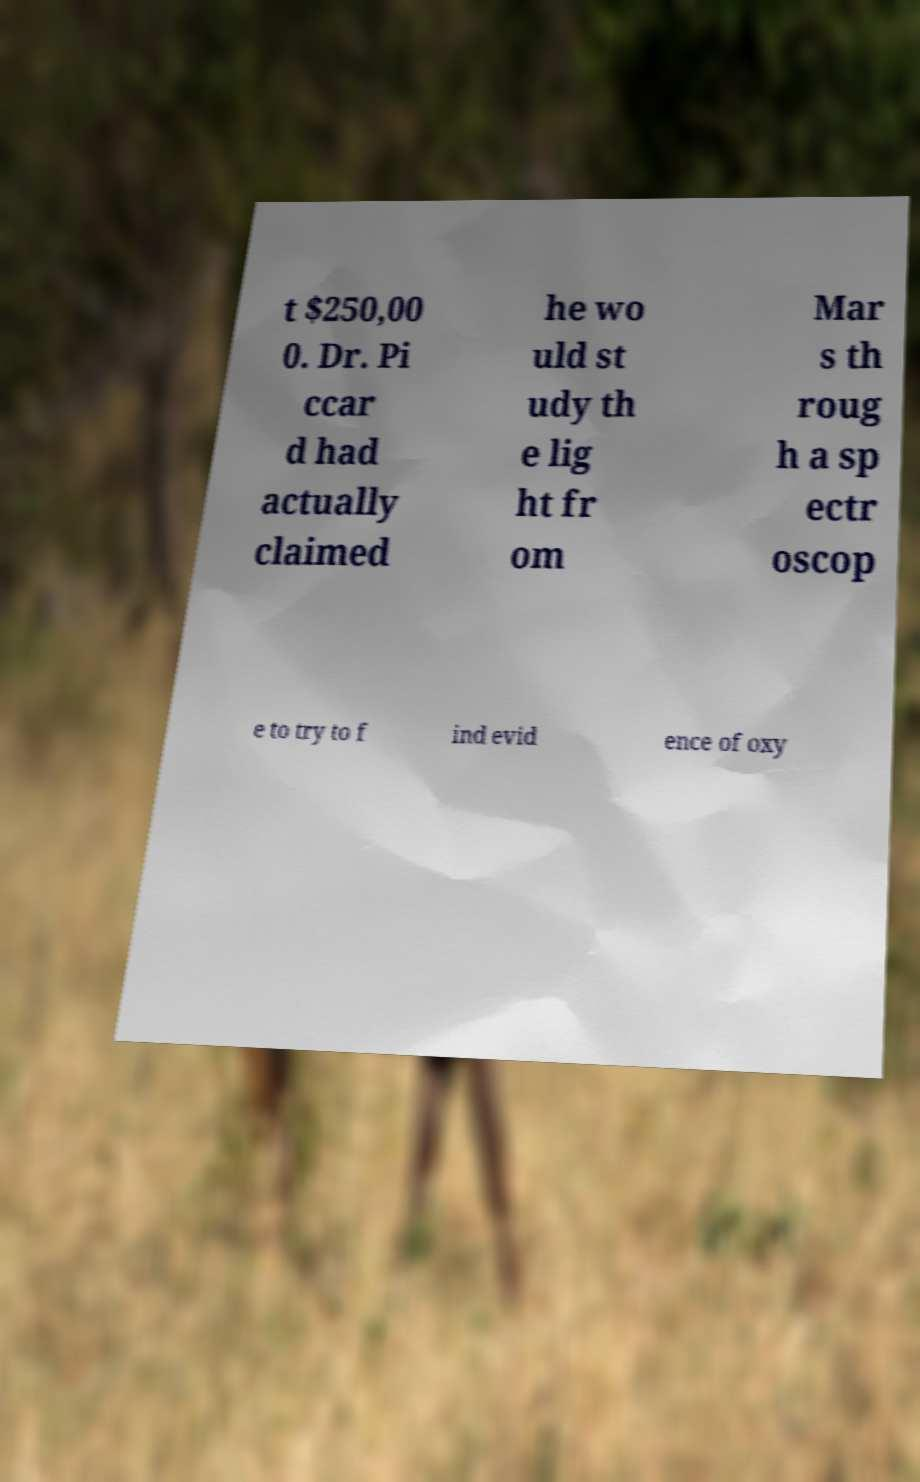Can you read and provide the text displayed in the image?This photo seems to have some interesting text. Can you extract and type it out for me? t $250,00 0. Dr. Pi ccar d had actually claimed he wo uld st udy th e lig ht fr om Mar s th roug h a sp ectr oscop e to try to f ind evid ence of oxy 